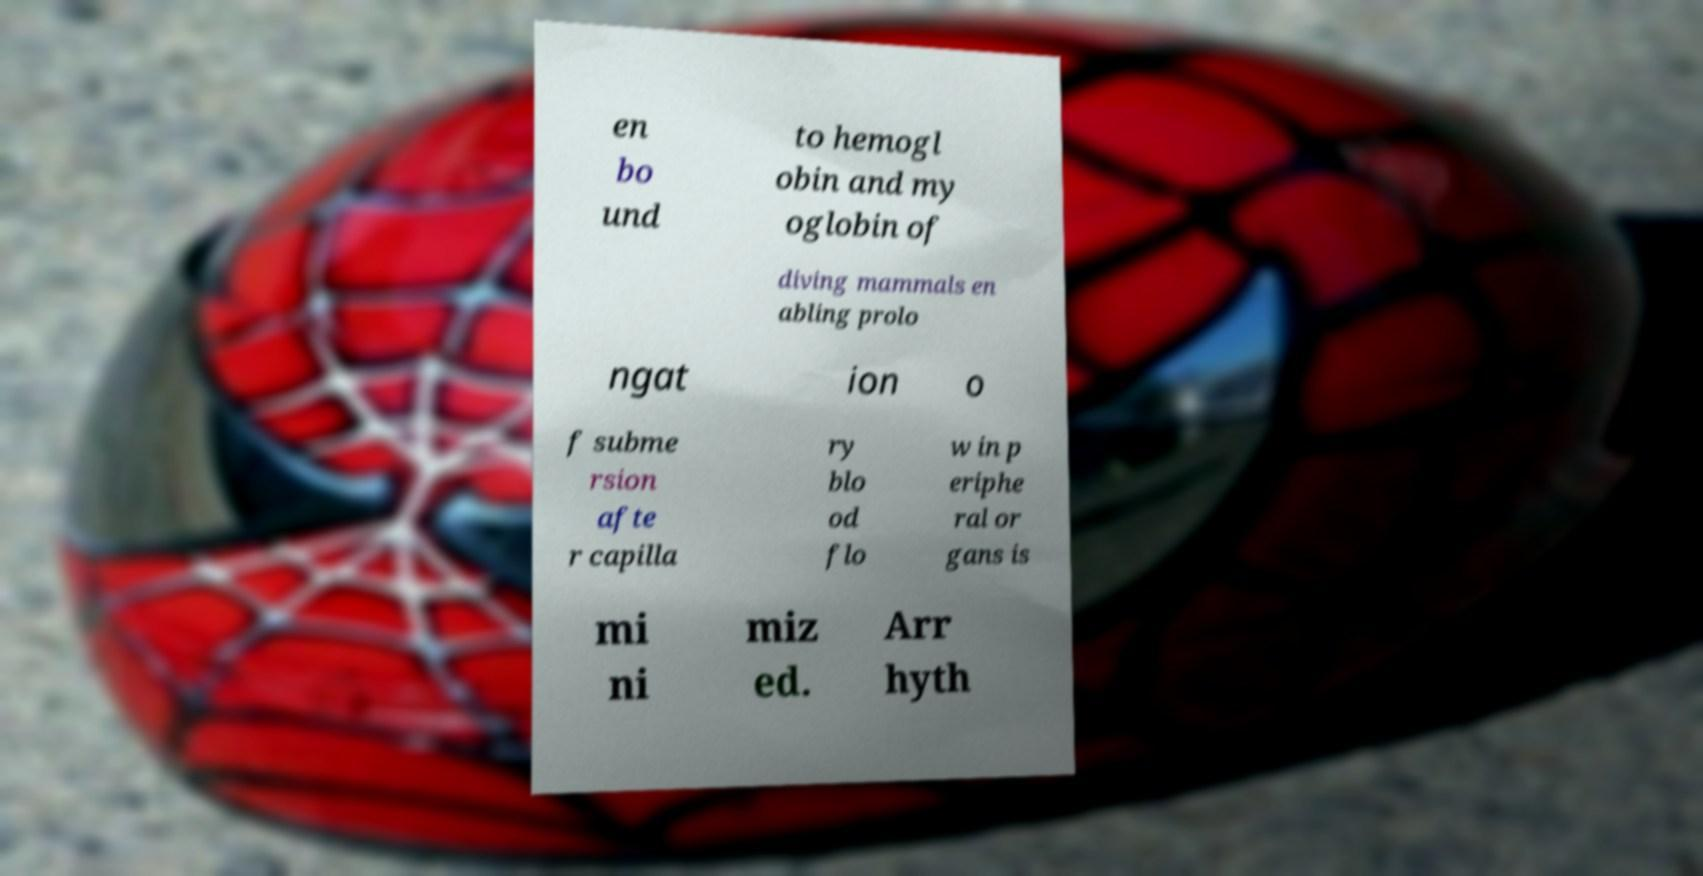Could you extract and type out the text from this image? en bo und to hemogl obin and my oglobin of diving mammals en abling prolo ngat ion o f subme rsion afte r capilla ry blo od flo w in p eriphe ral or gans is mi ni miz ed. Arr hyth 